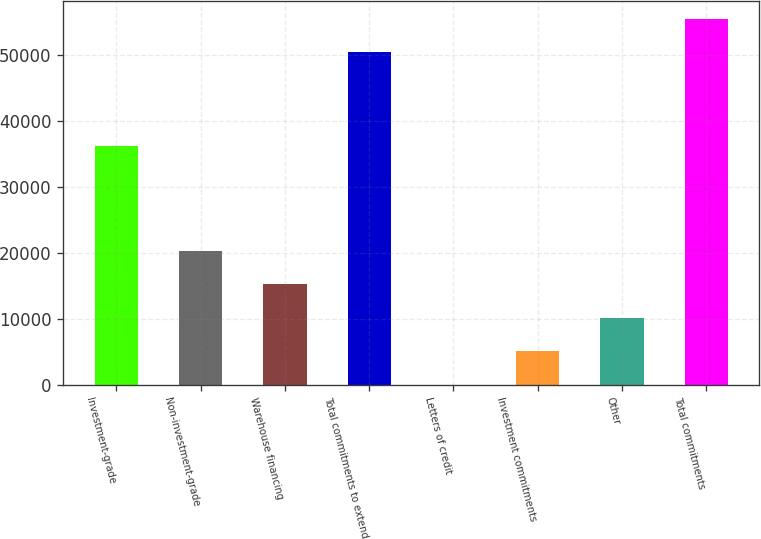Convert chart. <chart><loc_0><loc_0><loc_500><loc_500><bar_chart><fcel>Investment-grade<fcel>Non-investment-grade<fcel>Warehouse financing<fcel>Total commitments to extend<fcel>Letters of credit<fcel>Investment commitments<fcel>Other<fcel>Total commitments<nl><fcel>36200<fcel>20336<fcel>15254.5<fcel>50423<fcel>10<fcel>5091.5<fcel>10173<fcel>55504.5<nl></chart> 